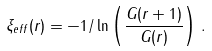<formula> <loc_0><loc_0><loc_500><loc_500>\xi _ { e f f } ( r ) = - 1 / \ln \left ( \frac { G ( r + 1 ) } { G ( r ) } \right ) \, .</formula> 